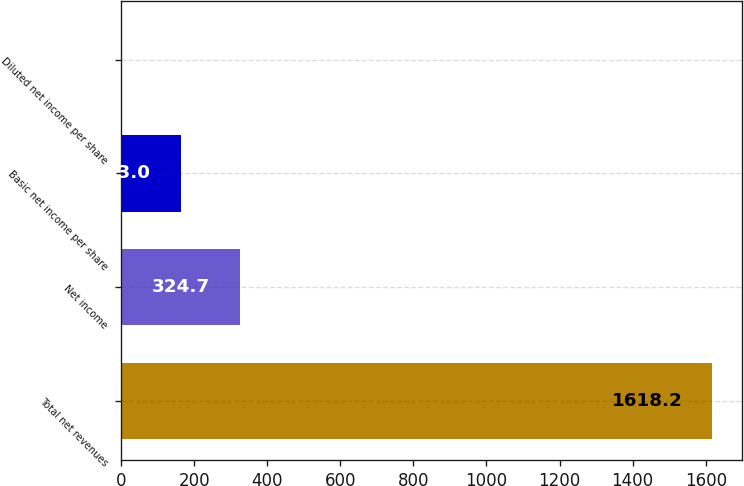Convert chart to OTSL. <chart><loc_0><loc_0><loc_500><loc_500><bar_chart><fcel>Total net revenues<fcel>Net income<fcel>Basic net income per share<fcel>Diluted net income per share<nl><fcel>1618.2<fcel>324.7<fcel>163<fcel>1.31<nl></chart> 